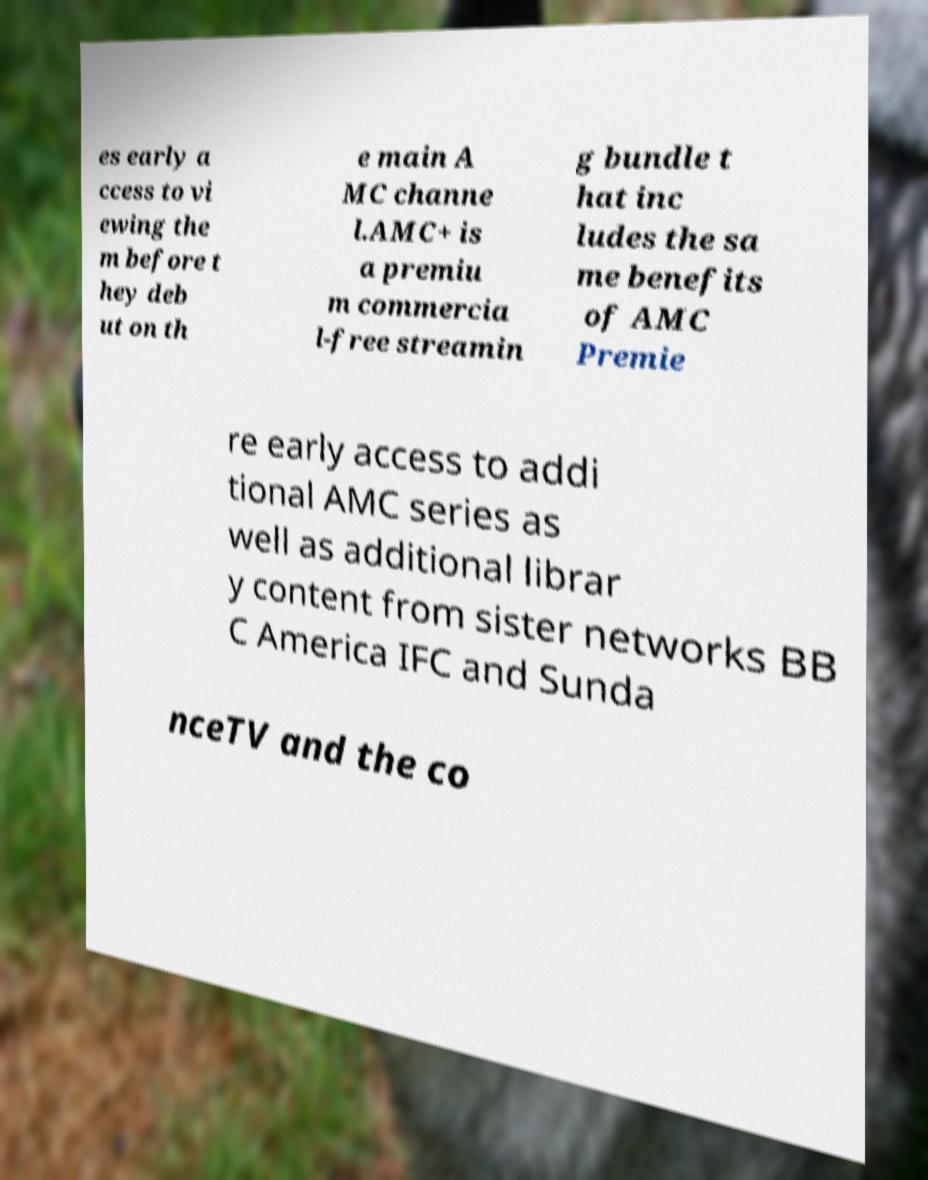Could you extract and type out the text from this image? es early a ccess to vi ewing the m before t hey deb ut on th e main A MC channe l.AMC+ is a premiu m commercia l-free streamin g bundle t hat inc ludes the sa me benefits of AMC Premie re early access to addi tional AMC series as well as additional librar y content from sister networks BB C America IFC and Sunda nceTV and the co 